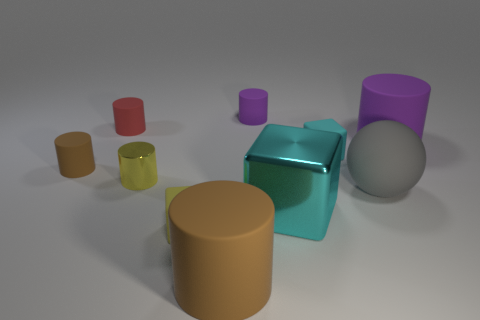How many other big objects have the same shape as the yellow metal thing?
Offer a very short reply. 2. What size is the red cylinder that is made of the same material as the tiny purple thing?
Provide a succinct answer. Small. There is a thing that is in front of the gray ball and to the left of the big brown object; what material is it made of?
Offer a very short reply. Rubber. What number of yellow metal objects are the same size as the cyan rubber block?
Your answer should be compact. 1. What material is the other cyan object that is the same shape as the tiny cyan rubber thing?
Your answer should be very brief. Metal. How many things are either big rubber cylinders that are on the right side of the gray matte sphere or tiny cylinders that are to the right of the tiny brown matte object?
Your response must be concise. 4. Is the shape of the large purple object the same as the large rubber object on the left side of the tiny purple cylinder?
Your answer should be very brief. Yes. There is a purple rubber object on the left side of the big cylinder that is behind the small object that is on the left side of the small red rubber thing; what is its shape?
Provide a short and direct response. Cylinder. How many other things are there of the same material as the tiny brown cylinder?
Your response must be concise. 7. What number of things are big matte cylinders that are to the right of the cyan matte thing or big shiny cubes?
Offer a very short reply. 2. 